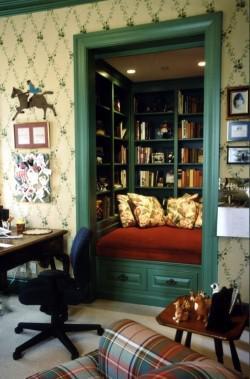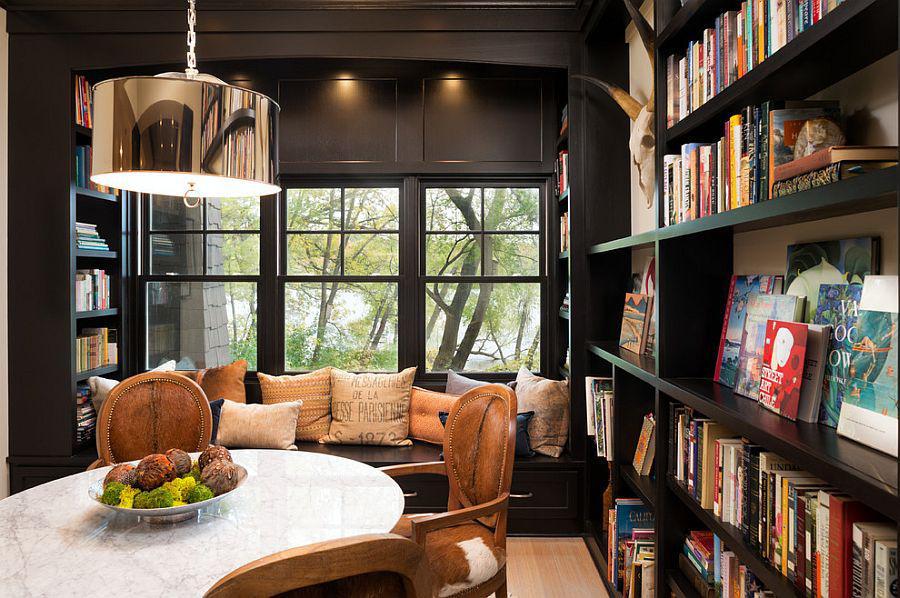The first image is the image on the left, the second image is the image on the right. Examine the images to the left and right. Is the description "In one image, a round dining table with chairs and centerpiece is located near large bookshelves." accurate? Answer yes or no. Yes. 